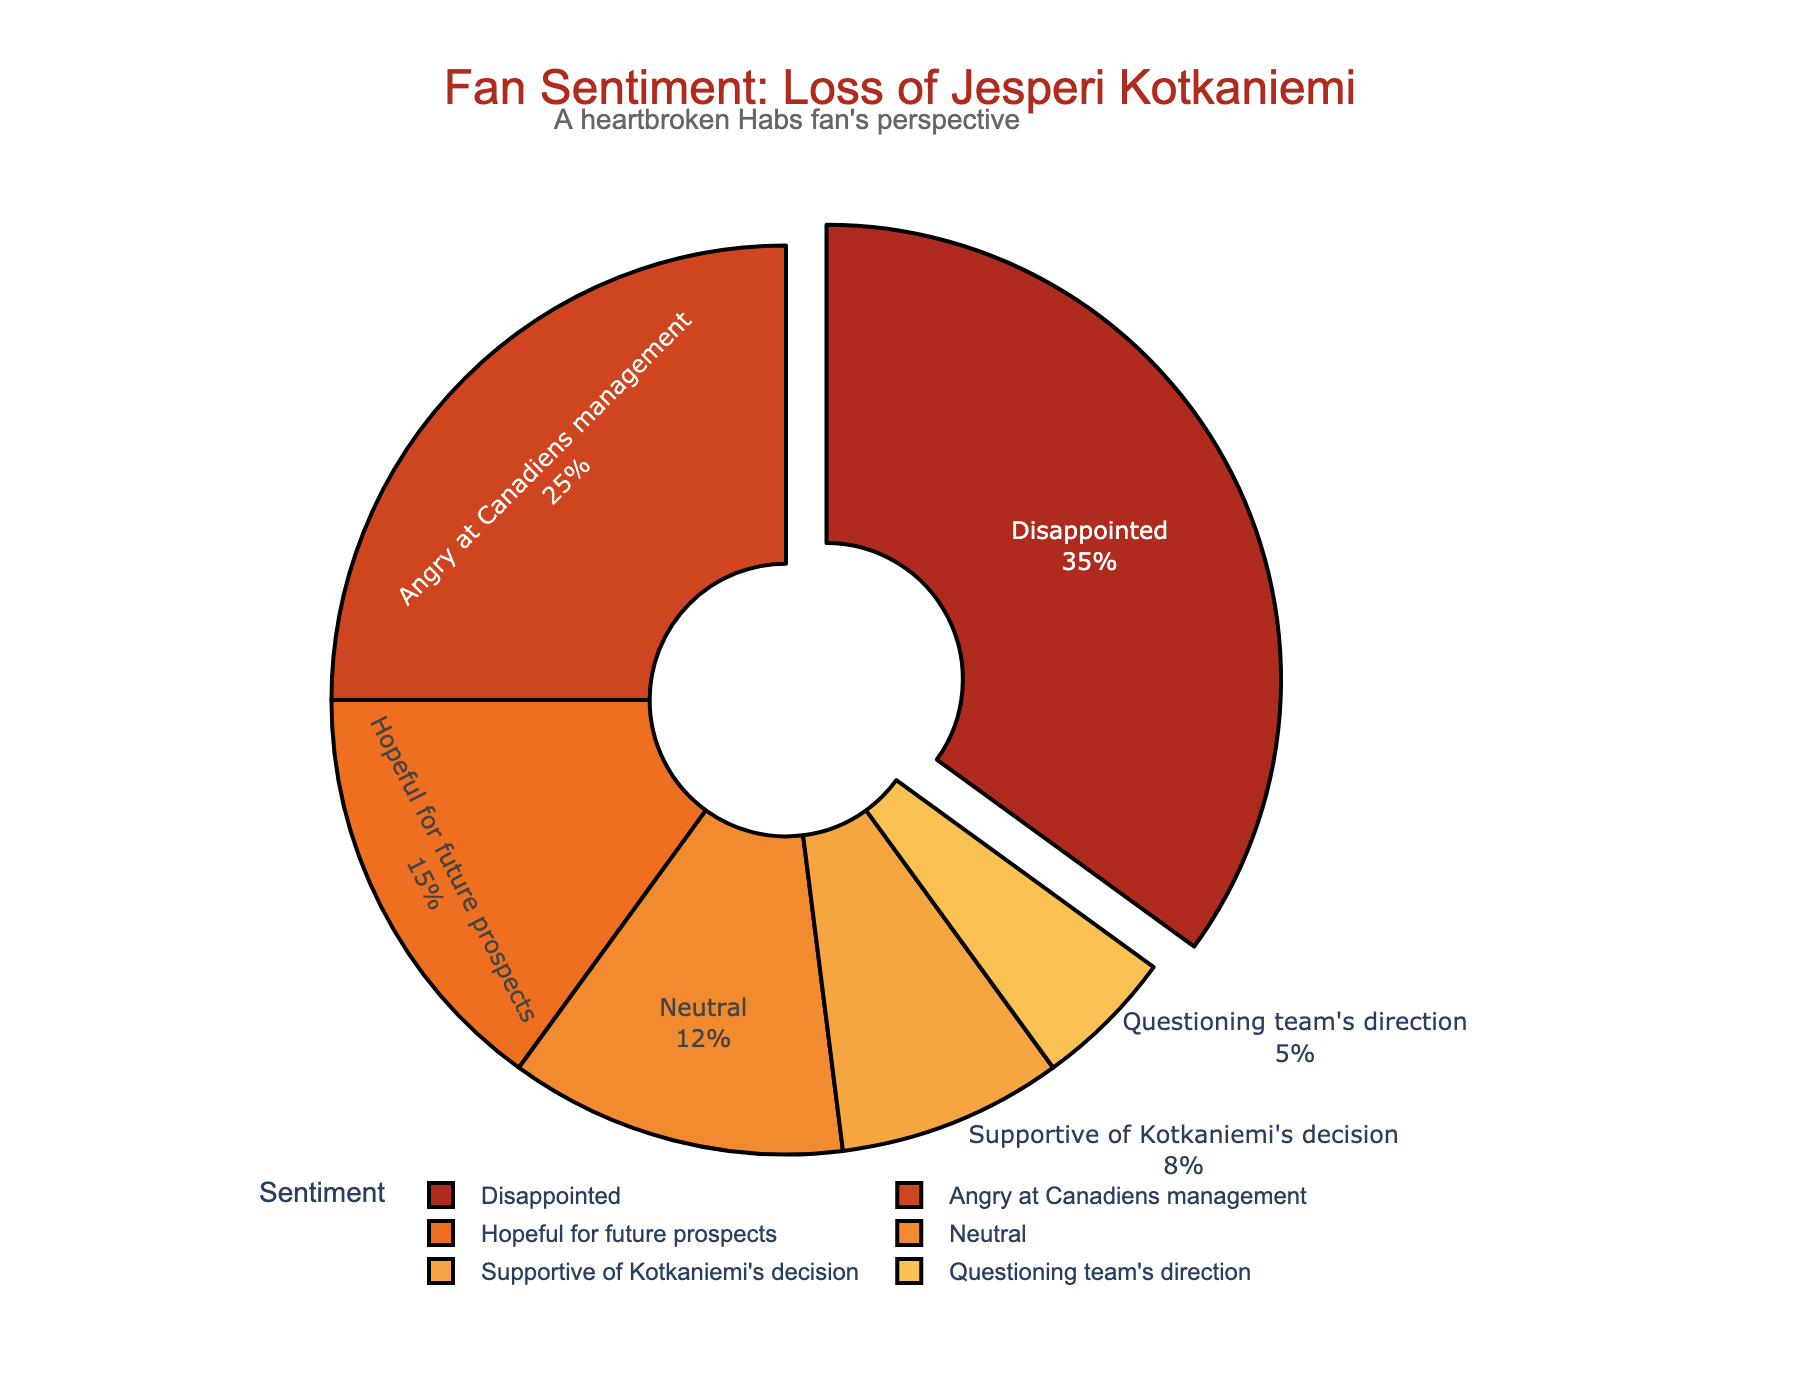What's the total percentage of fans who are either disappointed or angry at Canadiens management? Sum the percentages for the sentiments "Disappointed" (35%) and "Angry at Canadiens management" (25%). Therefore, 35% + 25% = 60%
Answer: 60% Which sentiment has the lowest percentage? Look for the sentiment with the smallest percentage in the chart; "Questioning team's direction" is given 5%, which is the lowest
Answer: Questioning team's direction How much more is the percentage of fans who are disappointed compared to those who support Kotkaniemi's decision? Subtract the percentage of "Supportive of Kotkaniemi's decision" (8%) from "Disappointed" (35%). Therefore, 35% - 8% = 27%
Answer: 27% Are more fans hopeful about future prospects than questioning the team's direction? Compare the percentages of "Hopeful for future prospects" (15%) and "Questioning team's direction" (5%). Since 15% > 5%, more fans are hopeful about future prospects
Answer: Yes What is the combined percentage of fans who have positive (Supportive of Kotkaniemi's decision and Hopeful for future prospects) sentiments? Add the percentages of "Supportive of Kotkaniemi's decision" (8%) and "Hopeful for future prospects" (15%). Therefore, 8% + 15% = 23%
Answer: 23% Which sentiment is represented by a segment pulled slightly out of the pie chart? Look at the visual cue in the pie chart for the segment that is slightly pulled out, which is "Disappointed"
Answer: Disappointed By what percentage is the "Neutral" sentiment lower than the "Angry at Canadiens management" sentiment? Subtract the percentage of "Neutral" (12%) from "Angry at Canadiens management" (25%). Therefore, 25% - 12% = 13%
Answer: 13% Which sentiment shares the same color as the pie chart's title text? Identify the color of the pie chart's title text, which is matched with "Disappointed"
Answer: Disappointed 